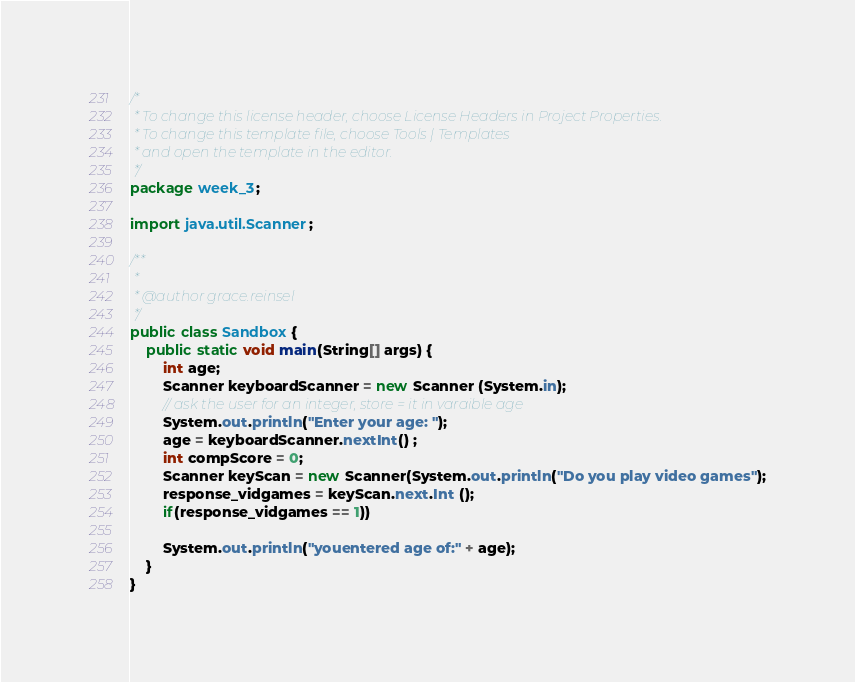Convert code to text. <code><loc_0><loc_0><loc_500><loc_500><_Java_>/*
 * To change this license header, choose License Headers in Project Properties.
 * To change this template file, choose Tools | Templates
 * and open the template in the editor.
 */
package week_3;

import java.util.Scanner;

/**
 *
 * @author grace.reinsel
 */
public class Sandbox {
    public static void main(String[] args) {
        int age;
        Scanner keyboardScanner = new Scanner (System.in);
        // ask the user for an integer, store = it in varaible age
        System.out.println("Enter your age: ");
        age = keyboardScanner.nextInt() ;
        int compScore = 0;
        Scanner keyScan = new Scanner(System.out.println("Do you play video games");
        response_vidgames = keyScan.next.Int ();
        if(response_vidgames == 1))
        
        System.out.println("youentered age of:" + age);
    }
}
</code> 